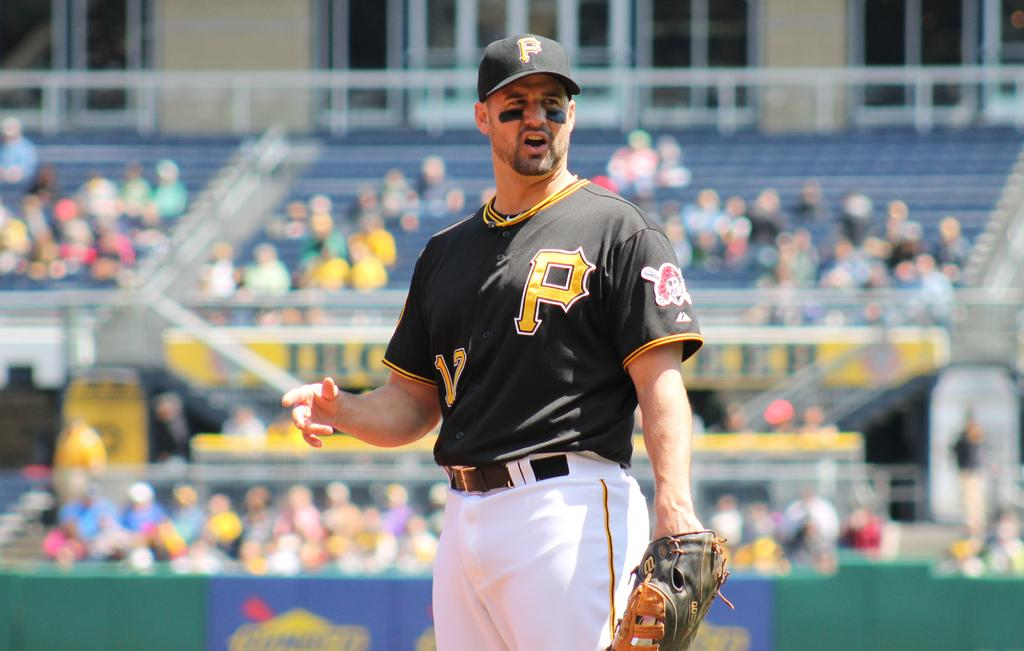<image>
Create a compact narrative representing the image presented. A baseball player with a yellow letter P on his black jersey. 